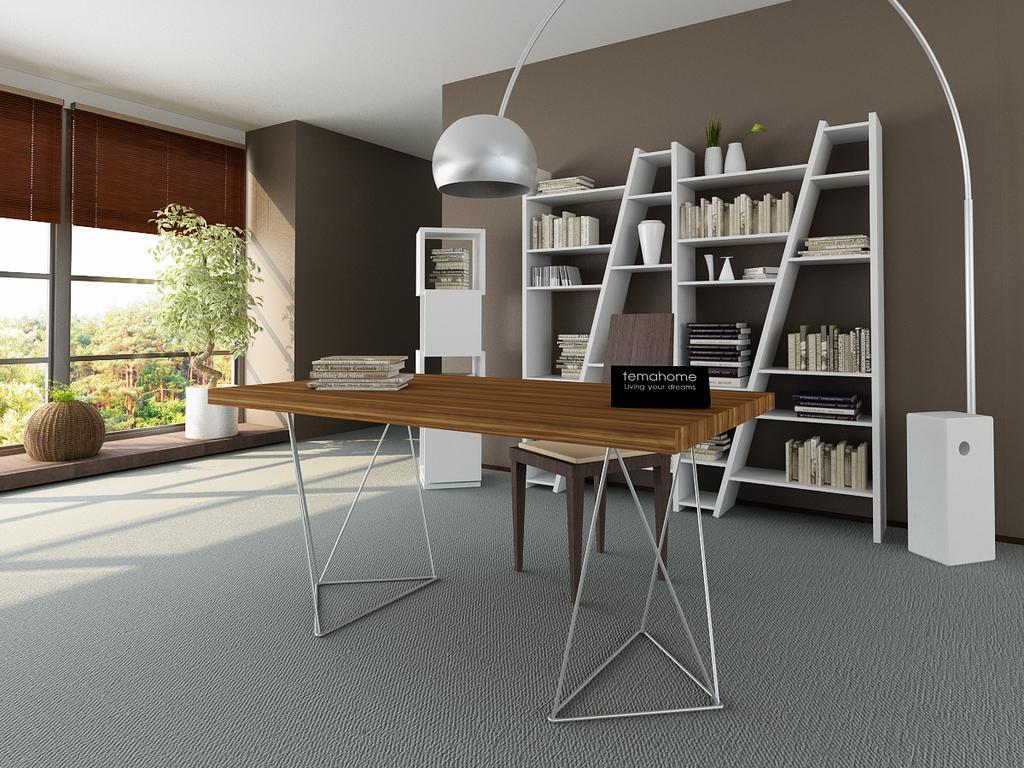In one or two sentences, can you explain what this image depicts? In this image there are few books and flower vases arranged on the shelves, there are books and a name board on the table, a chair, a light, flower pots beside the window, the wall, ceiling, outside the window there are few trees. 